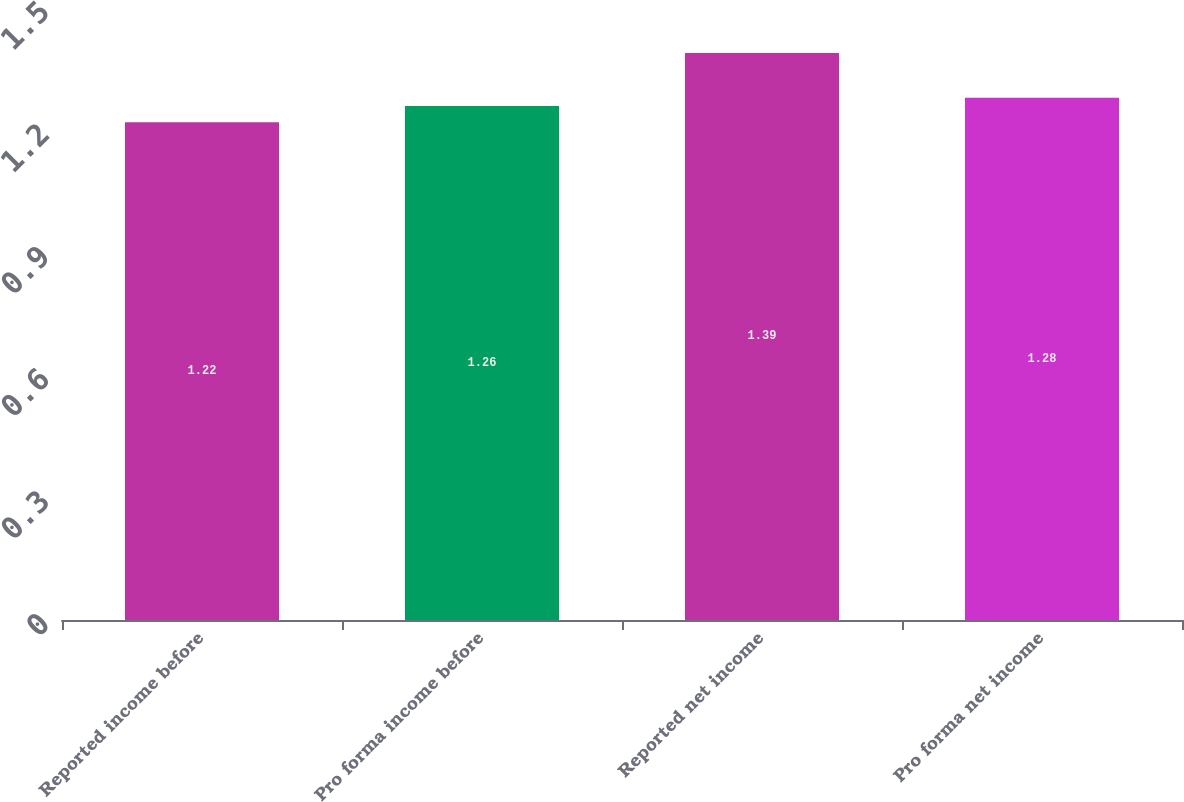Convert chart. <chart><loc_0><loc_0><loc_500><loc_500><bar_chart><fcel>Reported income before<fcel>Pro forma income before<fcel>Reported net income<fcel>Pro forma net income<nl><fcel>1.22<fcel>1.26<fcel>1.39<fcel>1.28<nl></chart> 